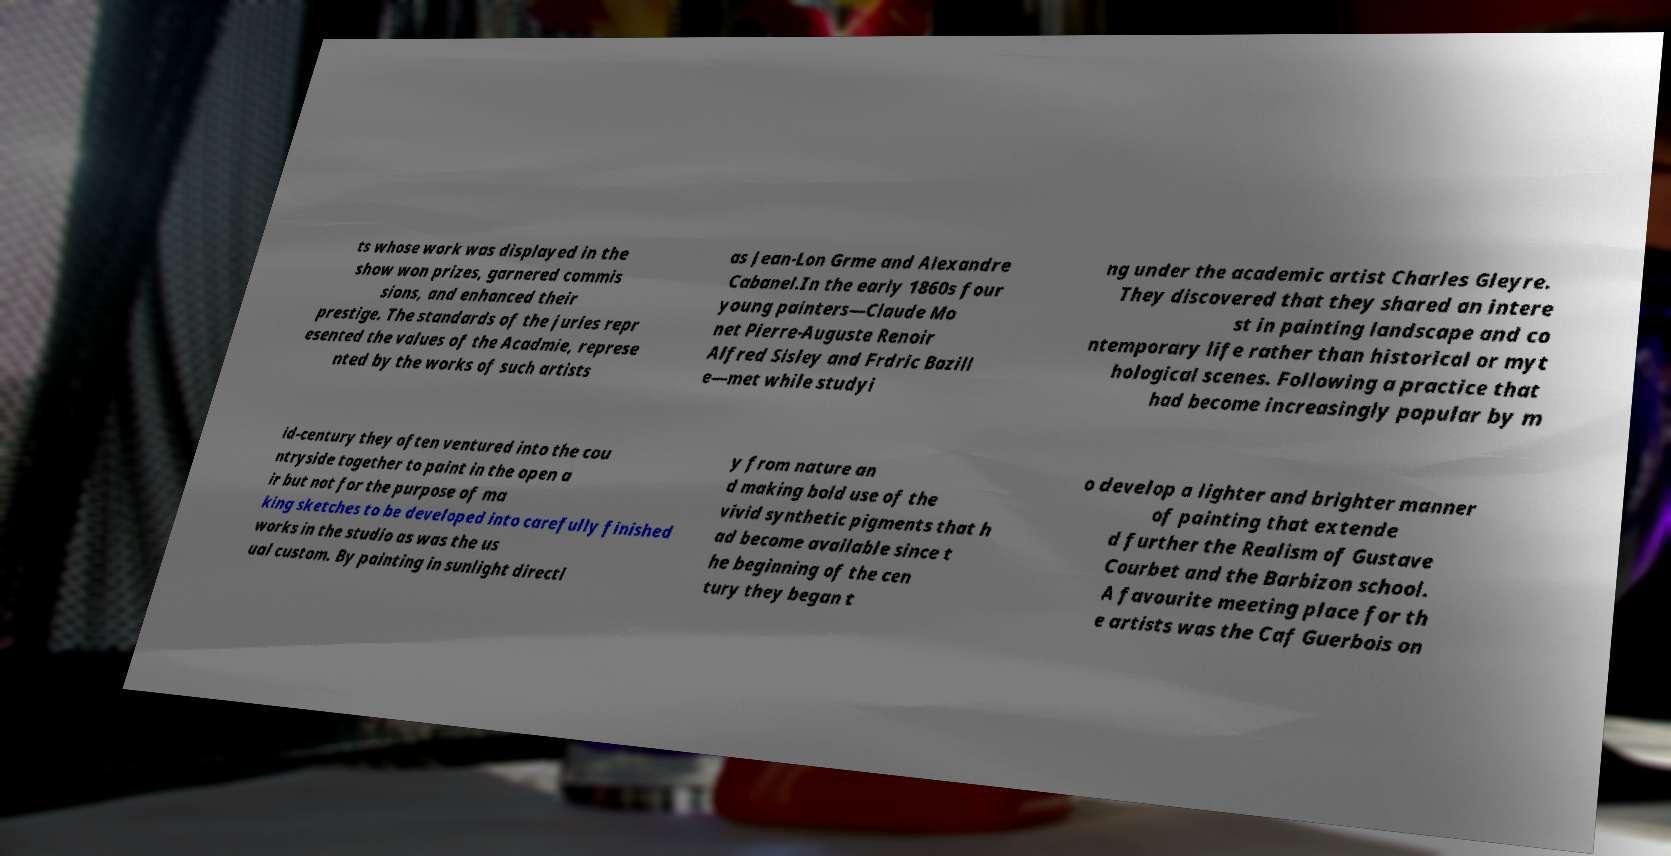What messages or text are displayed in this image? I need them in a readable, typed format. ts whose work was displayed in the show won prizes, garnered commis sions, and enhanced their prestige. The standards of the juries repr esented the values of the Acadmie, represe nted by the works of such artists as Jean-Lon Grme and Alexandre Cabanel.In the early 1860s four young painters—Claude Mo net Pierre-Auguste Renoir Alfred Sisley and Frdric Bazill e—met while studyi ng under the academic artist Charles Gleyre. They discovered that they shared an intere st in painting landscape and co ntemporary life rather than historical or myt hological scenes. Following a practice that had become increasingly popular by m id-century they often ventured into the cou ntryside together to paint in the open a ir but not for the purpose of ma king sketches to be developed into carefully finished works in the studio as was the us ual custom. By painting in sunlight directl y from nature an d making bold use of the vivid synthetic pigments that h ad become available since t he beginning of the cen tury they began t o develop a lighter and brighter manner of painting that extende d further the Realism of Gustave Courbet and the Barbizon school. A favourite meeting place for th e artists was the Caf Guerbois on 